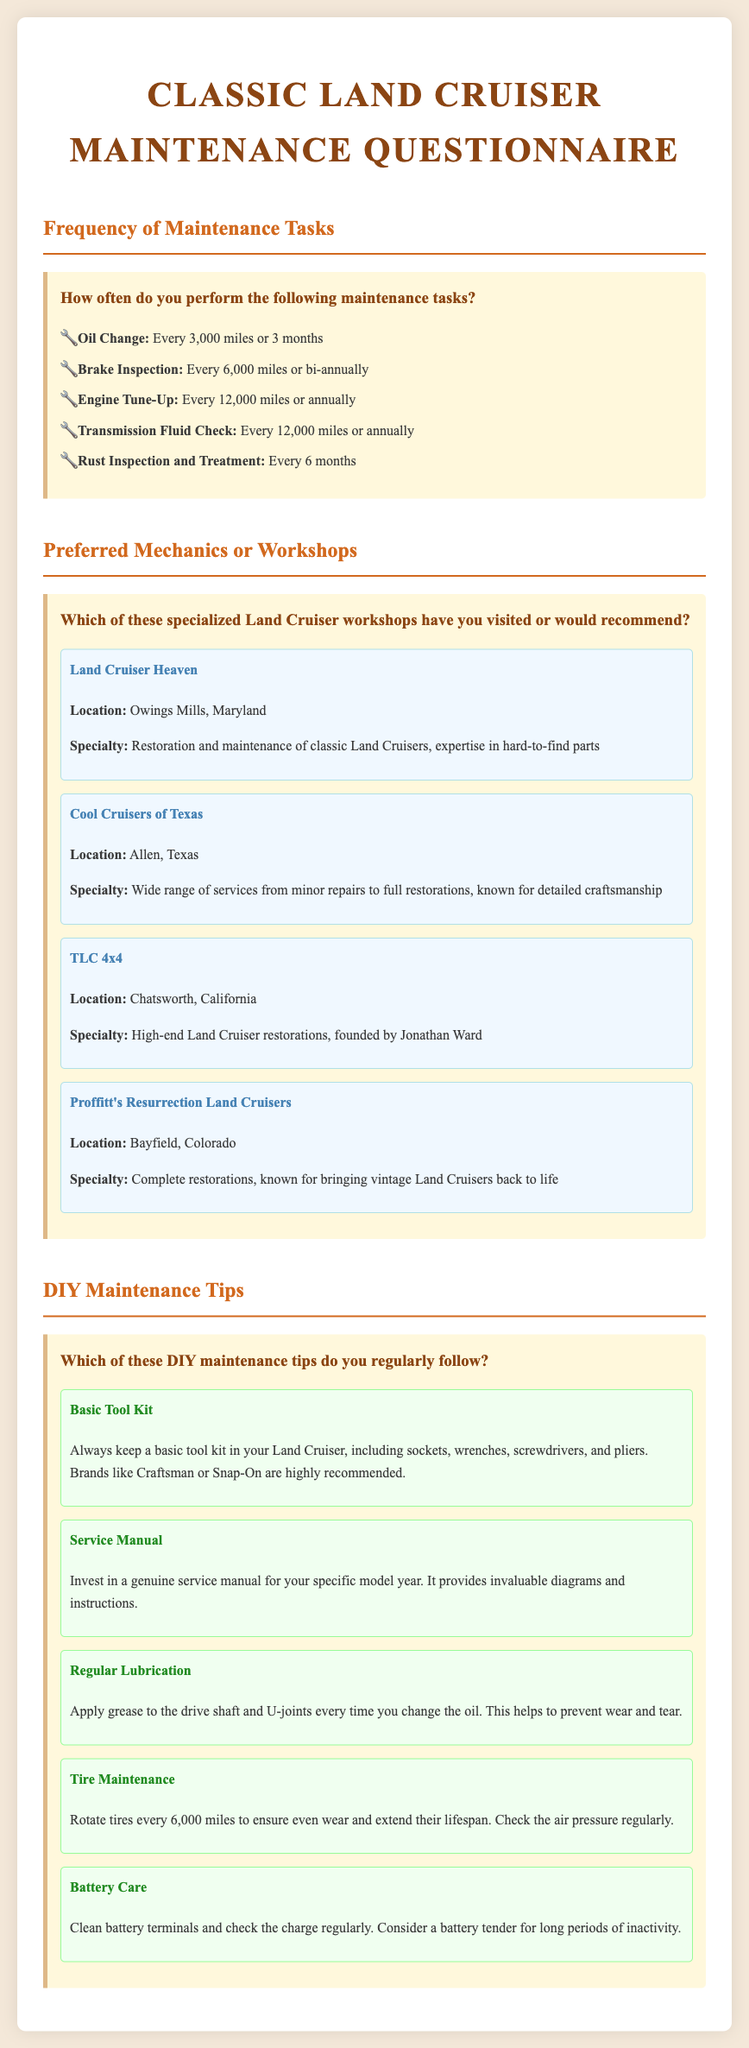How often should oil changes be performed? The document states that oil changes should be performed every 3,000 miles or 3 months.
Answer: Every 3,000 miles or 3 months What is the specialty of Land Cruiser Heaven? Land Cruiser Heaven specializes in restoration and maintenance of classic Land Cruisers, with expertise in hard-to-find parts.
Answer: Restoration and maintenance of classic Land Cruisers How frequently should tire rotation be done? The document specifies that tire rotation should be done every 6,000 miles to ensure even wear.
Answer: Every 6,000 miles What location is TLC 4x4 based in? The document mentions that TLC 4x4 is located in Chatsworth, California.
Answer: Chatsworth, California Which tool brands are recommended for a basic tool kit? The document suggests that brands like Craftsman or Snap-On are highly recommended for a basic tool kit.
Answer: Craftsman or Snap-On How often should rust inspection and treatment occur? According to the document, rust inspection and treatment should occur every 6 months.
Answer: Every 6 months What does the battery care tip suggest for long periods of inactivity? It suggests considering a battery tender for long periods of inactivity.
Answer: Battery tender How often should brake inspections be performed? The document states that brake inspections should be performed every 6,000 miles or bi-annually.
Answer: Every 6,000 miles or bi-annually What is the name of the workshop known for complete restorations in Colorado? The workshop known for complete restorations in Colorado is Proffitt's Resurrection Land Cruisers.
Answer: Proffitt's Resurrection Land Cruisers 